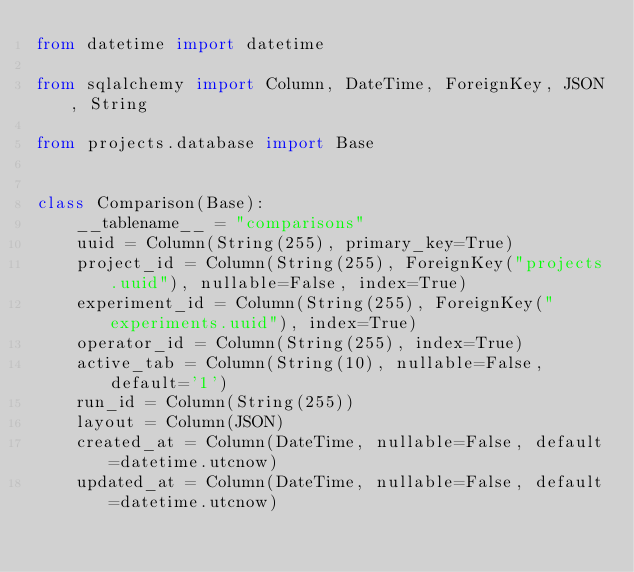Convert code to text. <code><loc_0><loc_0><loc_500><loc_500><_Python_>from datetime import datetime

from sqlalchemy import Column, DateTime, ForeignKey, JSON, String

from projects.database import Base


class Comparison(Base):
    __tablename__ = "comparisons"
    uuid = Column(String(255), primary_key=True)
    project_id = Column(String(255), ForeignKey("projects.uuid"), nullable=False, index=True)
    experiment_id = Column(String(255), ForeignKey("experiments.uuid"), index=True)
    operator_id = Column(String(255), index=True)
    active_tab = Column(String(10), nullable=False, default='1')
    run_id = Column(String(255))
    layout = Column(JSON)
    created_at = Column(DateTime, nullable=False, default=datetime.utcnow)
    updated_at = Column(DateTime, nullable=False, default=datetime.utcnow)
</code> 